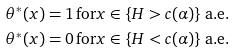Convert formula to latex. <formula><loc_0><loc_0><loc_500><loc_500>\theta ^ { \ast } ( x ) & = 1 \, \text {for} x \in \{ H > c ( \alpha ) \} \, \text {a.e.} \\ \theta ^ { \ast } ( x ) & = 0 \, \text {for} x \in \{ H < c ( \alpha ) \} \, \text {a.e.}</formula> 